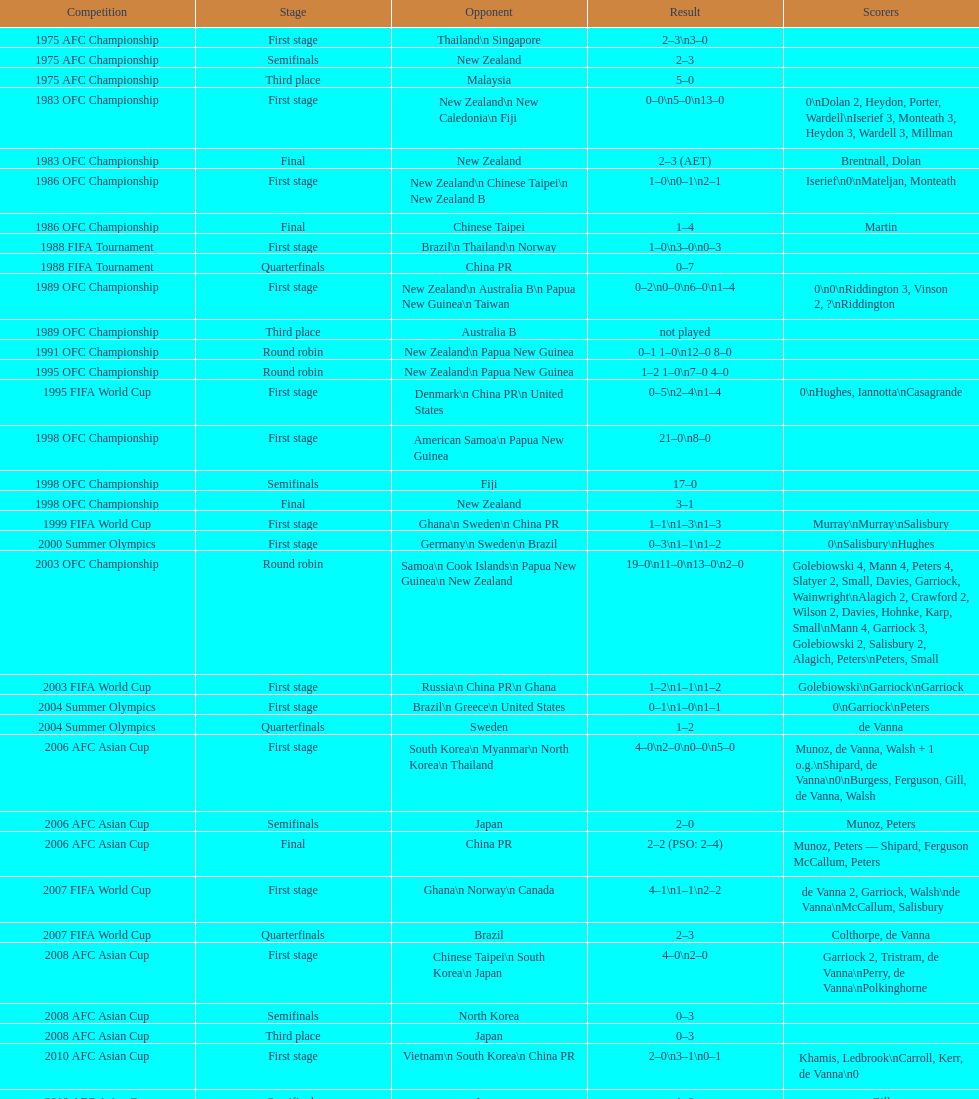What is the difference in the number of goals scored in the 1999 fifa world cup and the 2000 summer olympics? 2. 